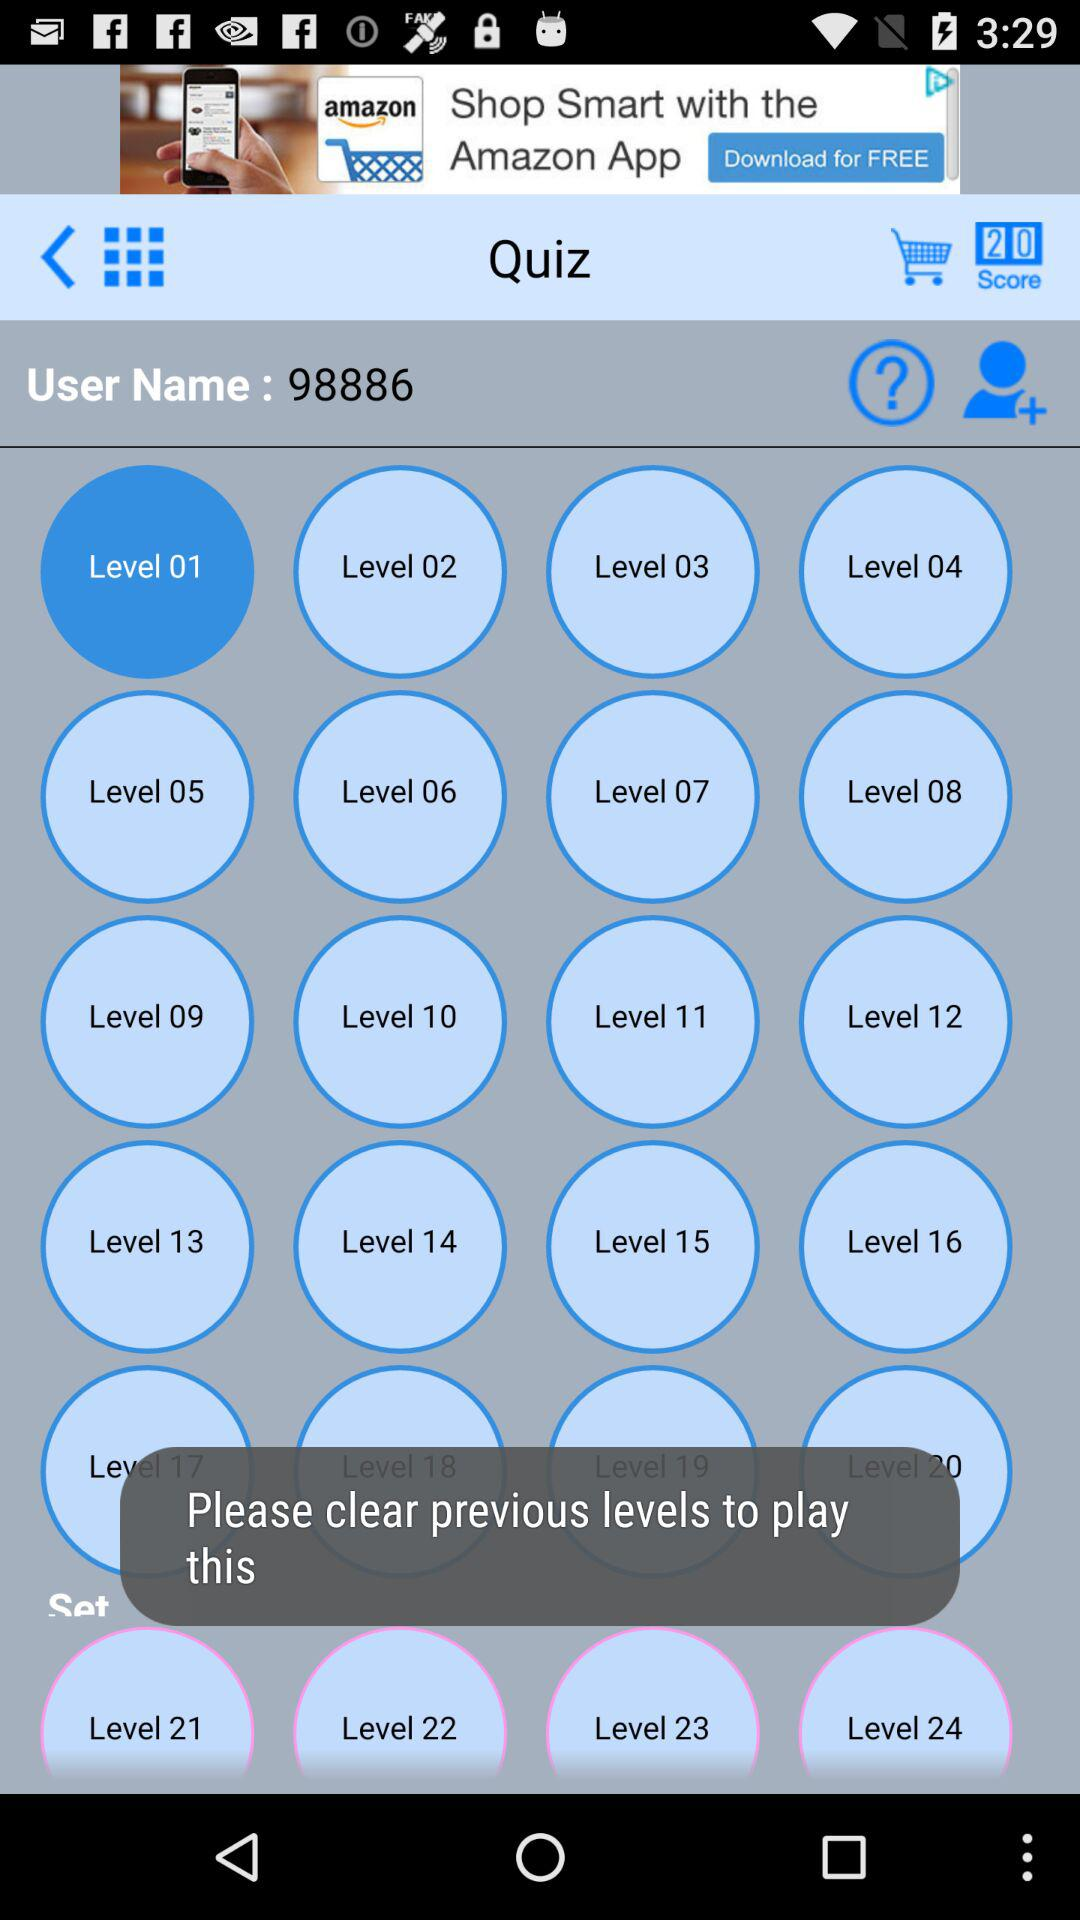How many levels are available in the game?
Answer the question using a single word or phrase. 24 